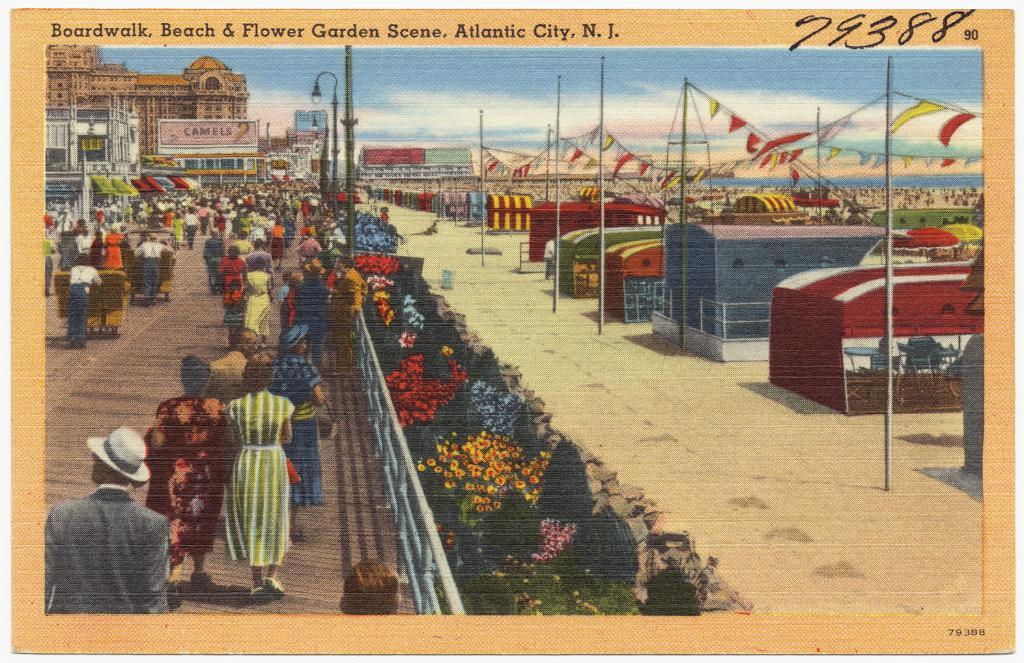<image>
Present a compact description of the photo's key features. A drawn depiction of the atlanta city boardwalk beach and flower garden. 